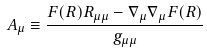<formula> <loc_0><loc_0><loc_500><loc_500>A _ { \mu } \equiv \frac { F ( R ) R _ { \mu \mu } - \nabla _ { \mu } \nabla _ { \mu } F ( R ) } { g _ { \mu \mu } }</formula> 